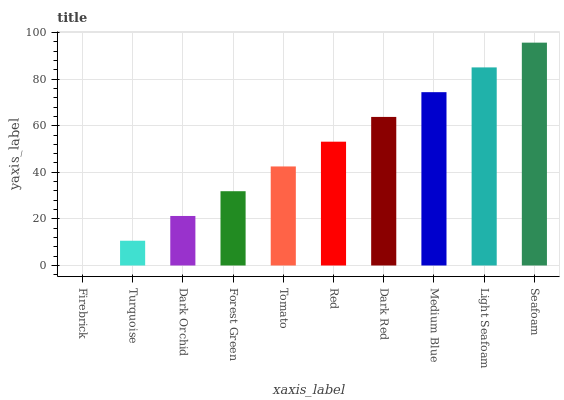Is Turquoise the minimum?
Answer yes or no. No. Is Turquoise the maximum?
Answer yes or no. No. Is Turquoise greater than Firebrick?
Answer yes or no. Yes. Is Firebrick less than Turquoise?
Answer yes or no. Yes. Is Firebrick greater than Turquoise?
Answer yes or no. No. Is Turquoise less than Firebrick?
Answer yes or no. No. Is Red the high median?
Answer yes or no. Yes. Is Tomato the low median?
Answer yes or no. Yes. Is Tomato the high median?
Answer yes or no. No. Is Medium Blue the low median?
Answer yes or no. No. 